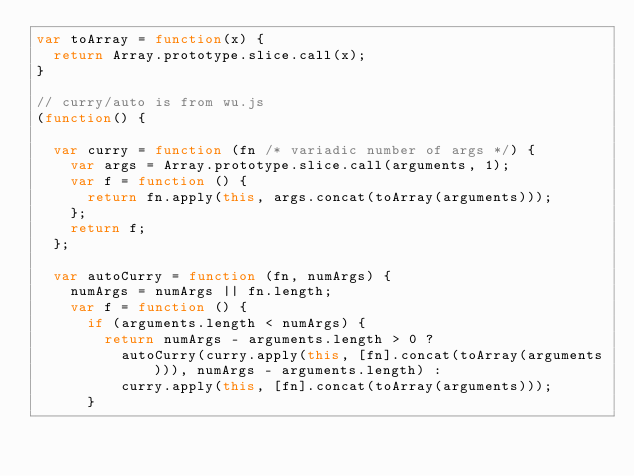<code> <loc_0><loc_0><loc_500><loc_500><_JavaScript_>var toArray = function(x) {
  return Array.prototype.slice.call(x);
}

// curry/auto is from wu.js
(function() {

  var curry = function (fn /* variadic number of args */) {
    var args = Array.prototype.slice.call(arguments, 1);
    var f = function () {
      return fn.apply(this, args.concat(toArray(arguments)));
    };
    return f;
  };

  var autoCurry = function (fn, numArgs) {
    numArgs = numArgs || fn.length;
    var f = function () {
      if (arguments.length < numArgs) {
        return numArgs - arguments.length > 0 ?
          autoCurry(curry.apply(this, [fn].concat(toArray(arguments))), numArgs - arguments.length) :
          curry.apply(this, [fn].concat(toArray(arguments)));
      }</code> 